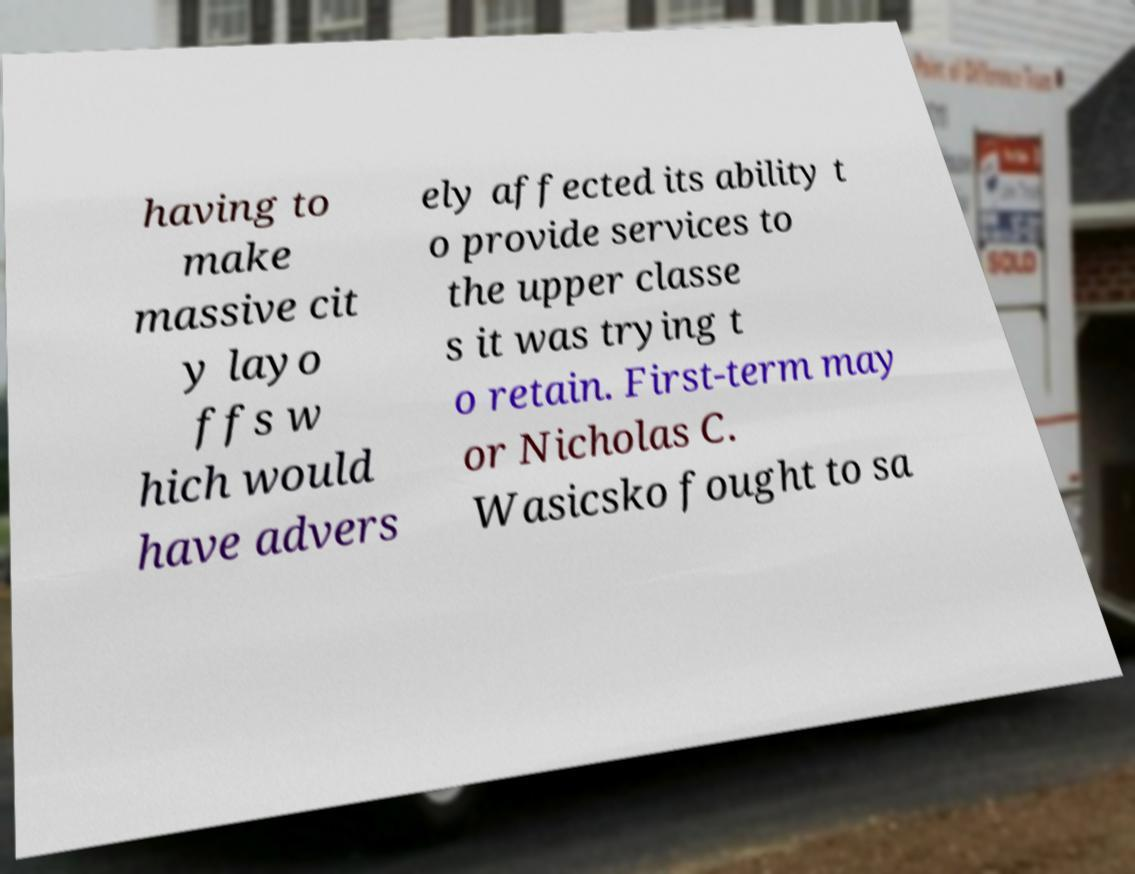Can you accurately transcribe the text from the provided image for me? having to make massive cit y layo ffs w hich would have advers ely affected its ability t o provide services to the upper classe s it was trying t o retain. First-term may or Nicholas C. Wasicsko fought to sa 